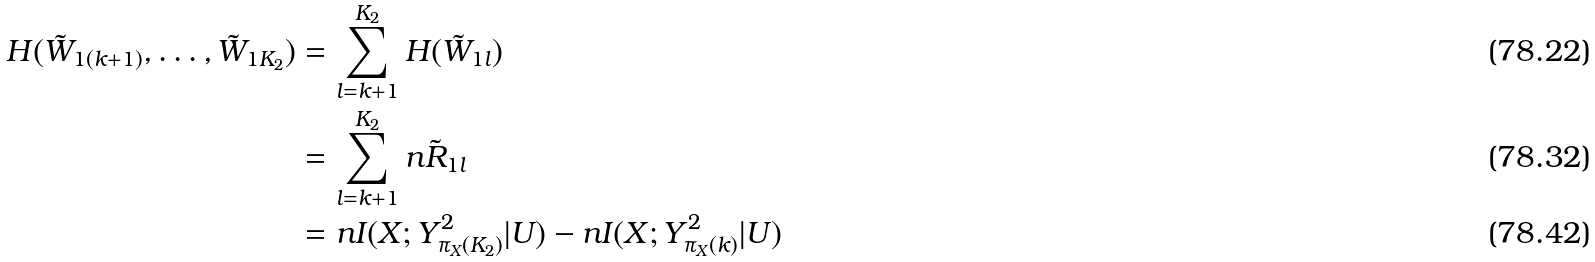<formula> <loc_0><loc_0><loc_500><loc_500>H ( \tilde { W } _ { 1 ( k + 1 ) } , \dots , \tilde { W } _ { 1 K _ { 2 } } ) & = \sum _ { l = k + 1 } ^ { K _ { 2 } } H ( \tilde { W } _ { 1 l } ) \\ & = \sum _ { l = k + 1 } ^ { K _ { 2 } } n \tilde { R } _ { 1 l } \\ & = n I ( X ; Y _ { \pi _ { X } ( K _ { 2 } ) } ^ { 2 } | U ) - n I ( X ; Y _ { \pi _ { X } ( k ) } ^ { 2 } | U )</formula> 